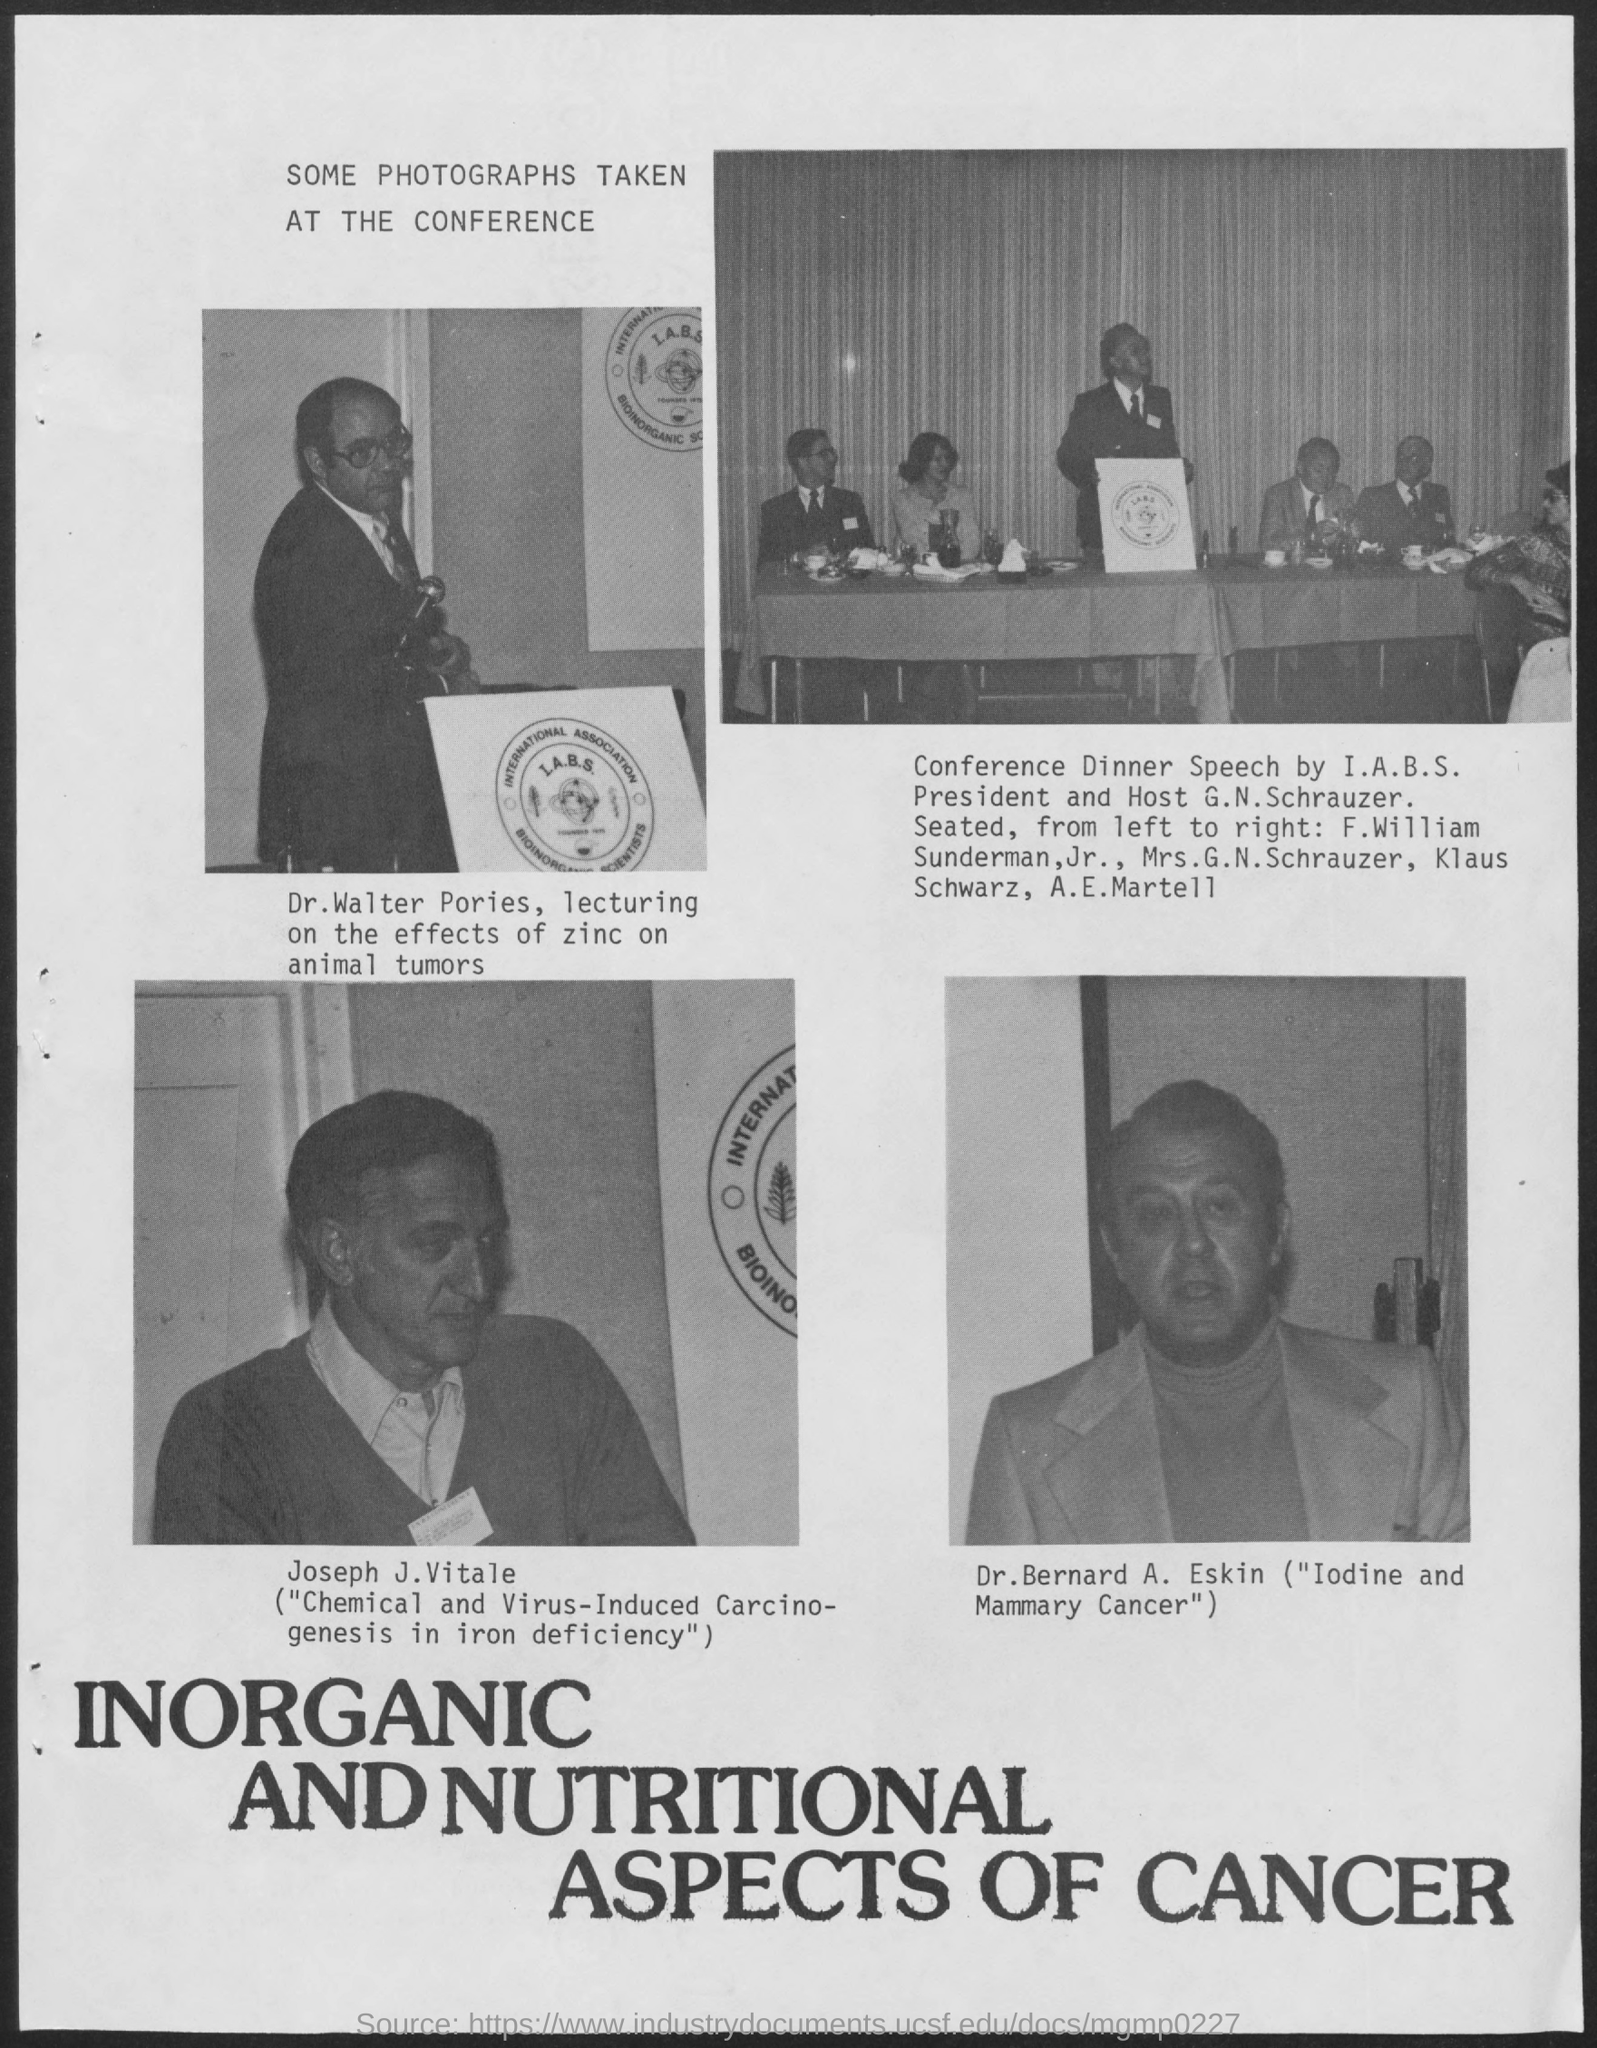Highlight a few significant elements in this photo. The image that is displayed in the lower right corner of the document is Dr. Bernard A. Eskin's image. 